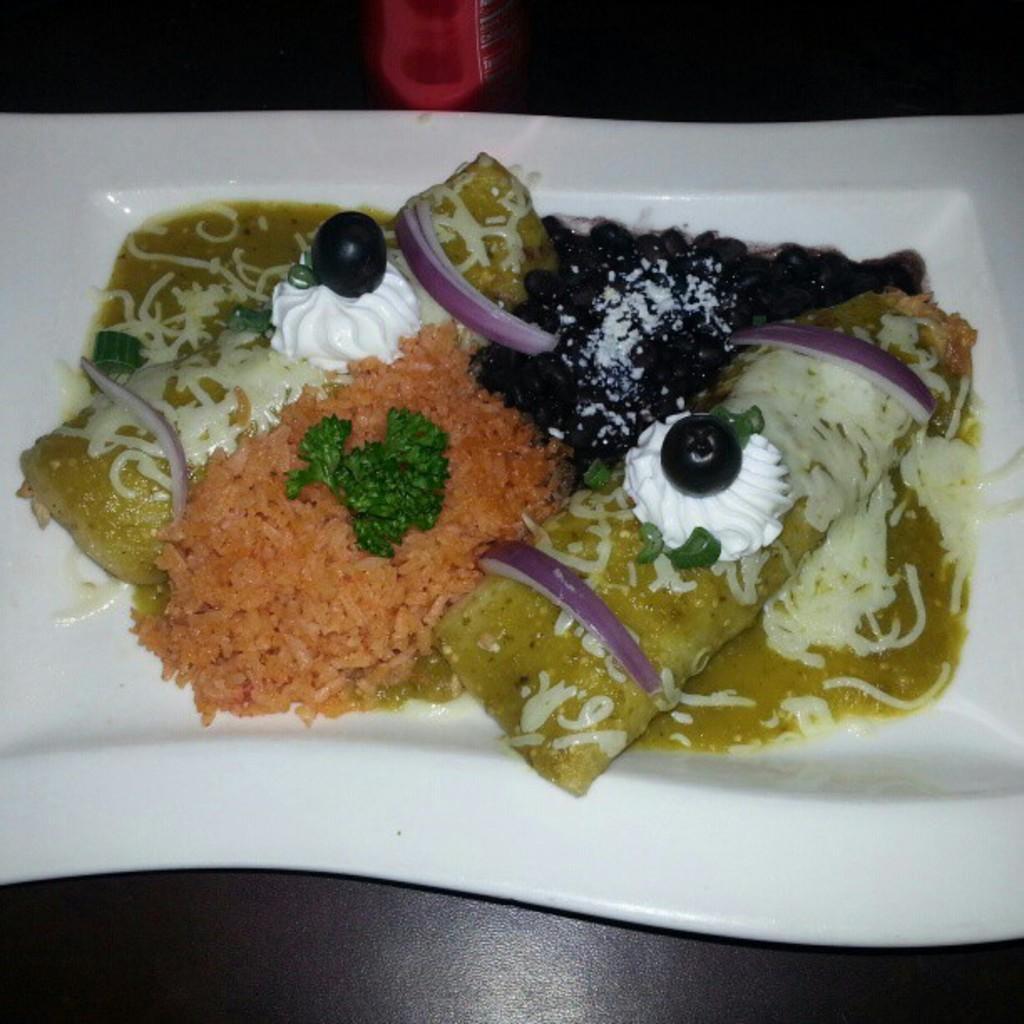In one or two sentences, can you explain what this image depicts? As we can see in the image there is a table. On table there is a white color plate. On plate there is a dish. 